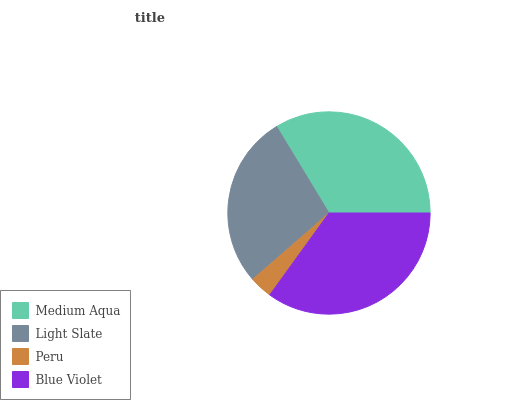Is Peru the minimum?
Answer yes or no. Yes. Is Blue Violet the maximum?
Answer yes or no. Yes. Is Light Slate the minimum?
Answer yes or no. No. Is Light Slate the maximum?
Answer yes or no. No. Is Medium Aqua greater than Light Slate?
Answer yes or no. Yes. Is Light Slate less than Medium Aqua?
Answer yes or no. Yes. Is Light Slate greater than Medium Aqua?
Answer yes or no. No. Is Medium Aqua less than Light Slate?
Answer yes or no. No. Is Medium Aqua the high median?
Answer yes or no. Yes. Is Light Slate the low median?
Answer yes or no. Yes. Is Blue Violet the high median?
Answer yes or no. No. Is Peru the low median?
Answer yes or no. No. 